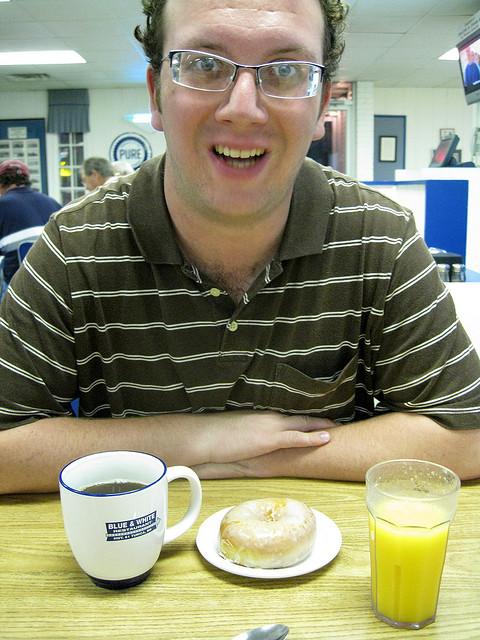Is that a donut or a bagel?
Concise answer only. Donut. Where is localized the TV?
Give a very brief answer. On upper right. What liquid is in the cup to the left?
Keep it brief. Coffee. 